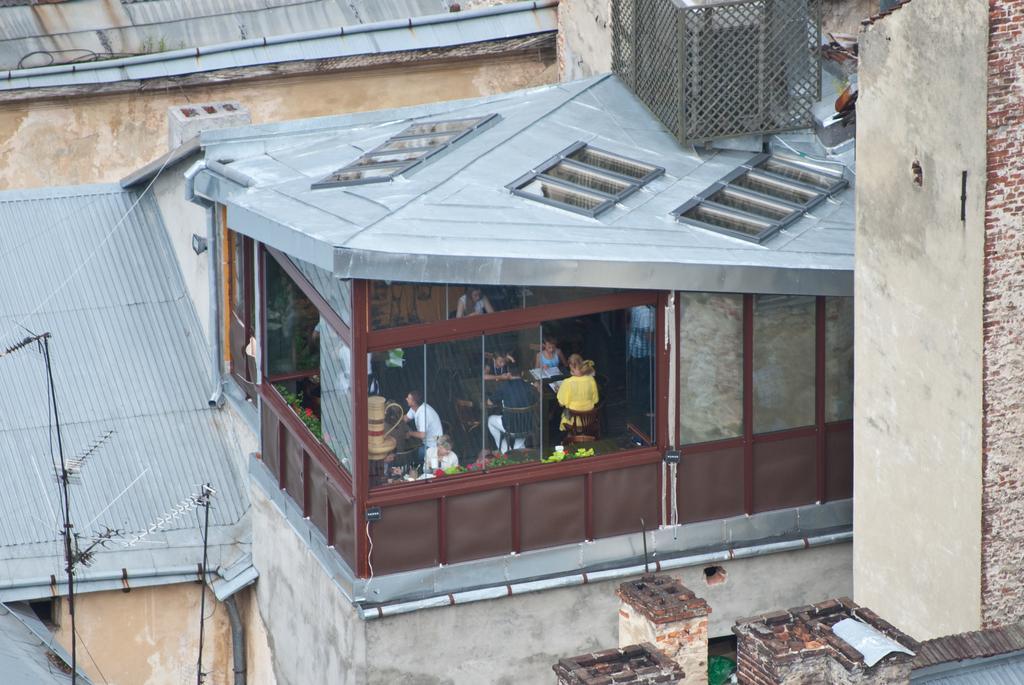Could you give a brief overview of what you see in this image? In this image, we can see a shop, there are some glass windows, we can see some people sitting in the shop, we can see the wall. 